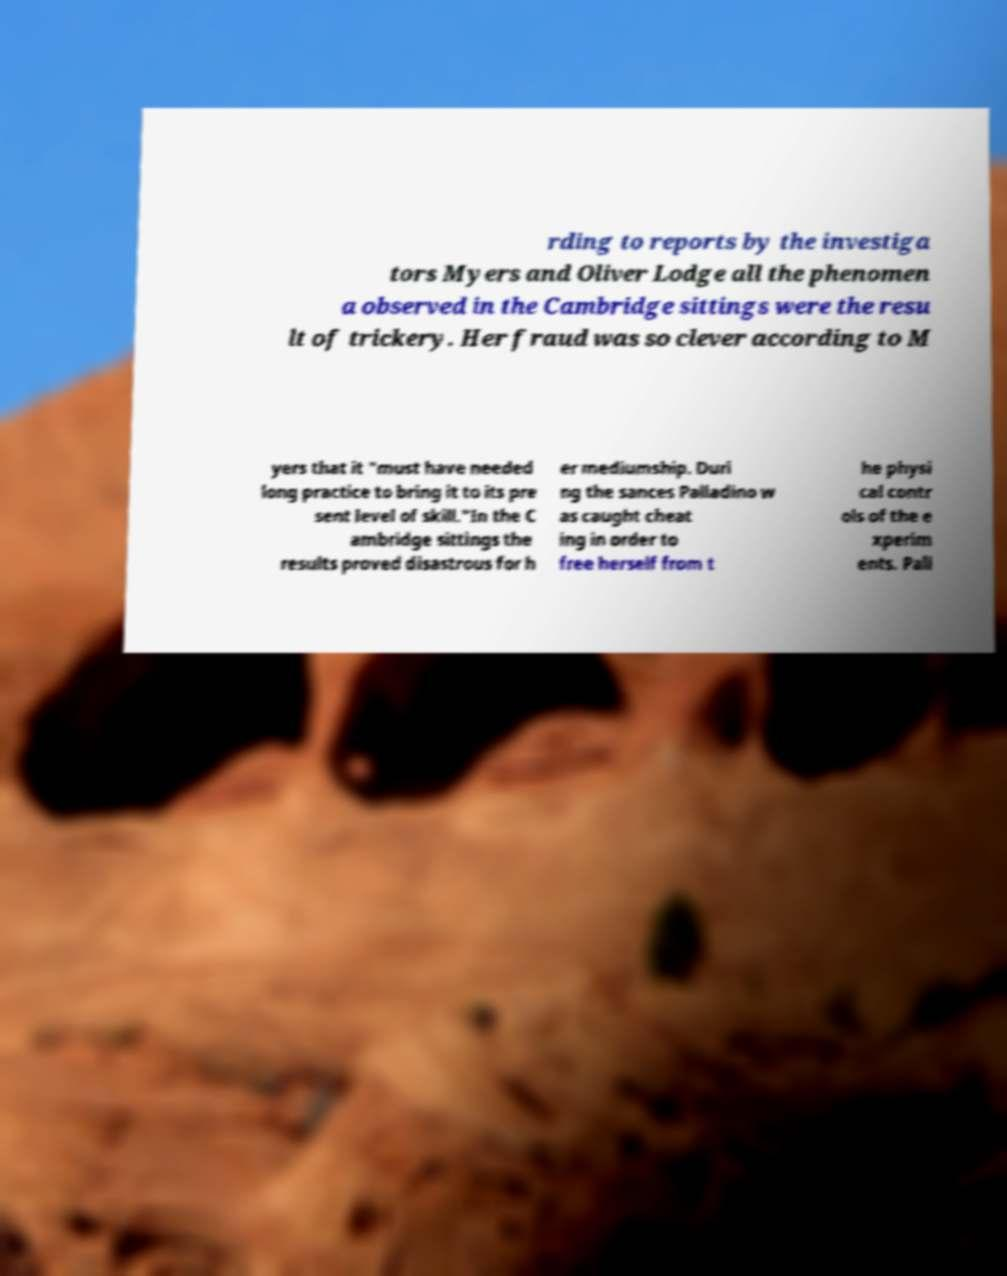There's text embedded in this image that I need extracted. Can you transcribe it verbatim? rding to reports by the investiga tors Myers and Oliver Lodge all the phenomen a observed in the Cambridge sittings were the resu lt of trickery. Her fraud was so clever according to M yers that it "must have needed long practice to bring it to its pre sent level of skill."In the C ambridge sittings the results proved disastrous for h er mediumship. Duri ng the sances Palladino w as caught cheat ing in order to free herself from t he physi cal contr ols of the e xperim ents. Pall 